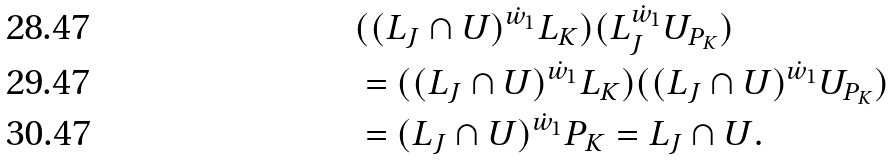<formula> <loc_0><loc_0><loc_500><loc_500>& ( ( L _ { J } \cap U ) ^ { \dot { w } _ { 1 } } L _ { K } ) ( L _ { J } ^ { \dot { w } _ { 1 } } U _ { P _ { K } } ) \\ & = ( ( L _ { J } \cap U ) ^ { \dot { w } _ { 1 } } L _ { K } ) ( ( L _ { J } \cap U ) ^ { \dot { w } _ { 1 } } U _ { P _ { K } } ) \\ & = ( L _ { J } \cap U ) ^ { \dot { w } _ { 1 } } P _ { K } = L _ { J } \cap U .</formula> 